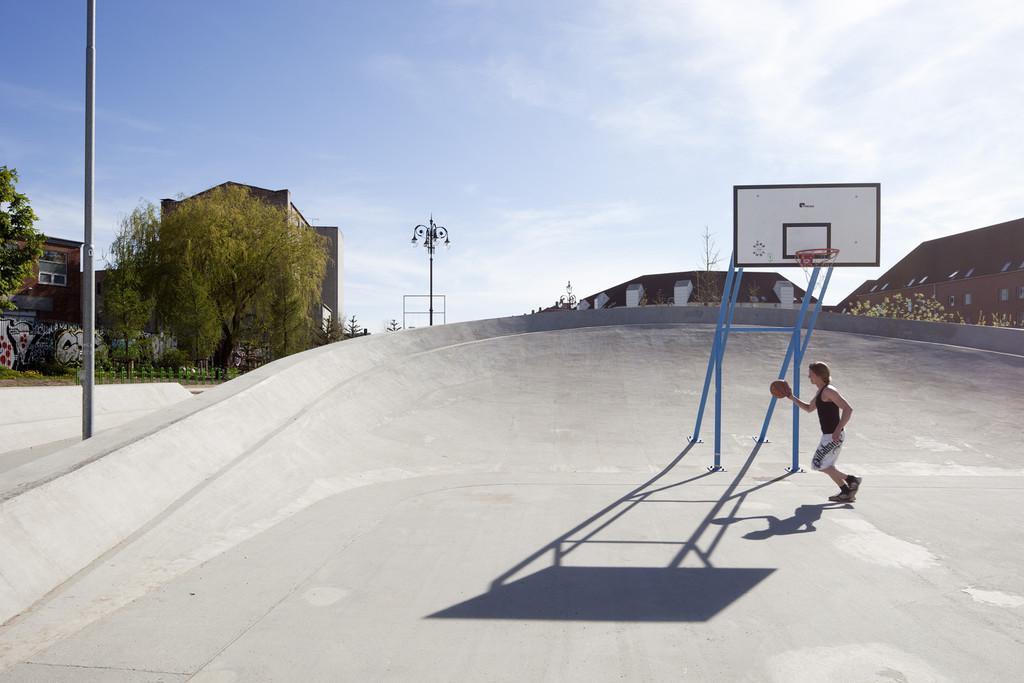Could you give a brief overview of what you see in this image? In this image I can see the floor, a basket ball goal post, a person standing and holding a basketball, few poles, few trees and few buildings. In the background I can see the sky. 